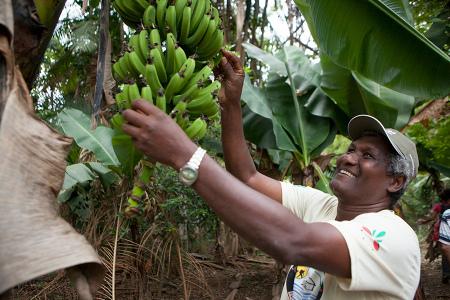What race is the man?
Answer briefly. Black. How many bracelets do you see?
Give a very brief answer. 0. What is this man picking?
Keep it brief. Bananas. What is the man wearing on his left wrist?
Be succinct. Watch. 